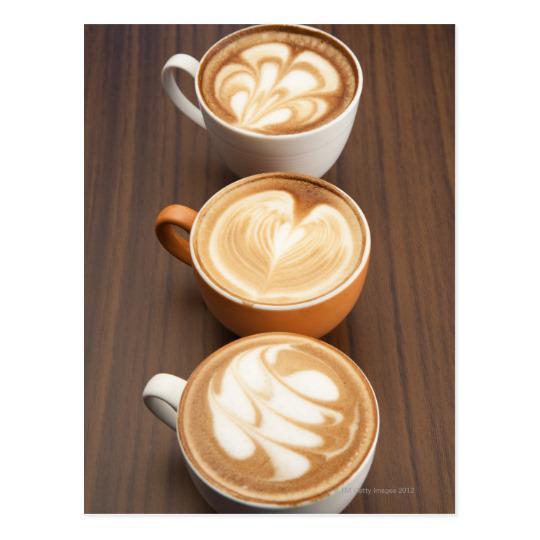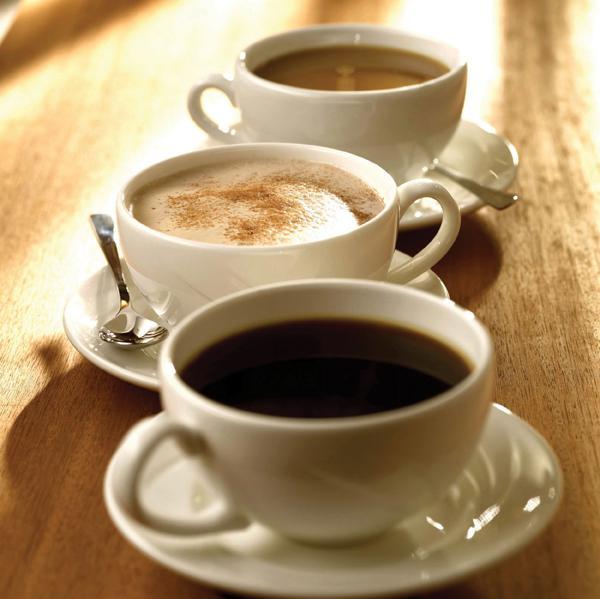The first image is the image on the left, the second image is the image on the right. Evaluate the accuracy of this statement regarding the images: "There is at least one spoon placed in a saucer.". Is it true? Answer yes or no. Yes. The first image is the image on the left, the second image is the image on the right. Examine the images to the left and right. Is the description "Cups in the right image are on saucers, and cups in the left image are not." accurate? Answer yes or no. Yes. 